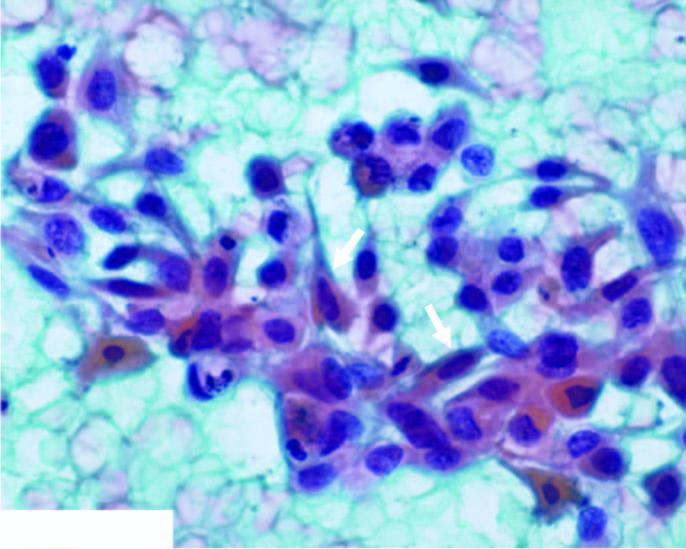does sectioned surface of the lung show abundant haemorrhage and some necrotic debris?
Answer the question using a single word or phrase. No 